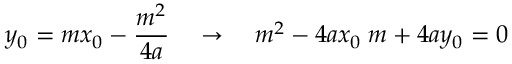Convert formula to latex. <formula><loc_0><loc_0><loc_500><loc_500>y _ { 0 } = m x _ { 0 } - { \frac { m ^ { 2 } } { 4 a } } \quad \rightarrow \quad m ^ { 2 } - 4 a x _ { 0 } \, m + 4 a y _ { 0 } = 0</formula> 